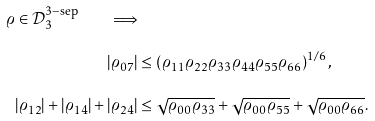Convert formula to latex. <formula><loc_0><loc_0><loc_500><loc_500>\varrho \in \mathcal { D } _ { 3 } ^ { 3 - \text {sep} } \quad \Longrightarrow & \\ | \varrho _ { 0 7 } | & \leq \left ( \varrho _ { 1 1 } \varrho _ { 2 2 } \varrho _ { 3 3 } \varrho _ { 4 4 } \varrho _ { 5 5 } \varrho _ { 6 6 } \right ) ^ { 1 / 6 } , \\ | \varrho _ { 1 2 } | + | \varrho _ { 1 4 } | + | \varrho _ { 2 4 } | & \leq \sqrt { \varrho _ { 0 0 } \varrho _ { 3 3 } } + \sqrt { \varrho _ { 0 0 } \varrho _ { 5 5 } } + \sqrt { \varrho _ { 0 0 } \varrho _ { 6 6 } } .</formula> 